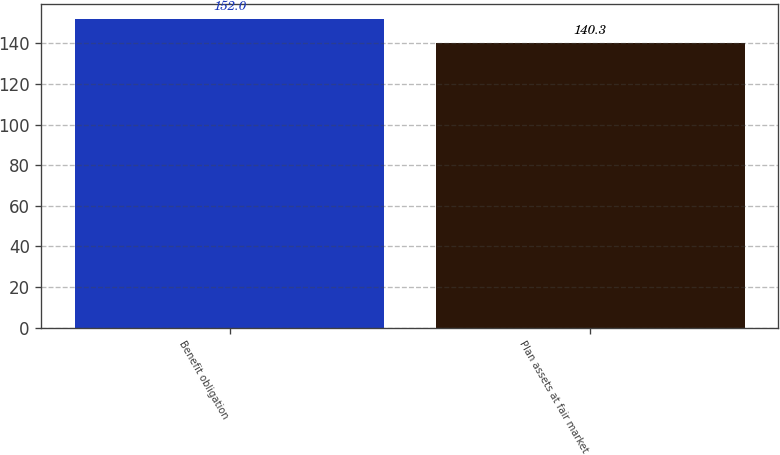Convert chart. <chart><loc_0><loc_0><loc_500><loc_500><bar_chart><fcel>Benefit obligation<fcel>Plan assets at fair market<nl><fcel>152<fcel>140.3<nl></chart> 